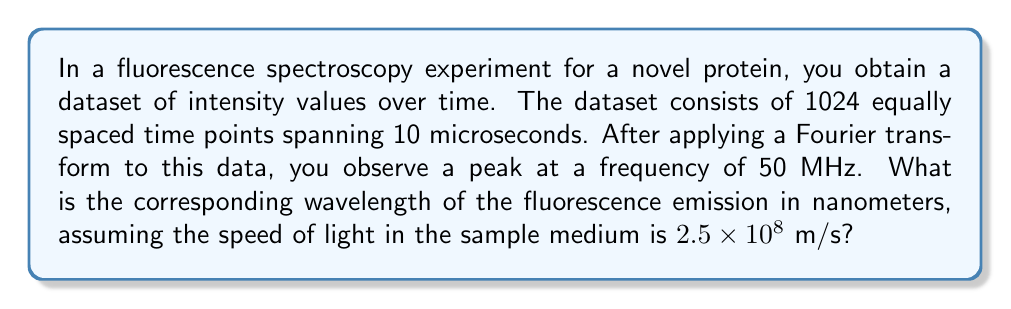Can you answer this question? To solve this problem, we'll follow these steps:

1. Identify the given information:
   - Frequency (f) = 50 MHz = $5 \times 10^7$ Hz
   - Speed of light in the medium (v) = $2.5 \times 10^8$ m/s

2. Recall the relationship between wavelength (λ), frequency (f), and wave velocity (v):
   $$ v = f \lambda $$

3. Rearrange the equation to solve for wavelength:
   $$ \lambda = \frac{v}{f} $$

4. Substitute the known values:
   $$ \lambda = \frac{2.5 \times 10^8 \text{ m/s}}{5 \times 10^7 \text{ Hz}} $$

5. Perform the calculation:
   $$ \lambda = 5 \text{ m} $$

6. Convert the result to nanometers:
   $$ \lambda = 5 \text{ m} \times \frac{10^9 \text{ nm}}{1 \text{ m}} = 5 \times 10^9 \text{ nm} $$

Therefore, the wavelength of the fluorescence emission is $5 \times 10^9$ nm.
Answer: $5 \times 10^9$ nm 